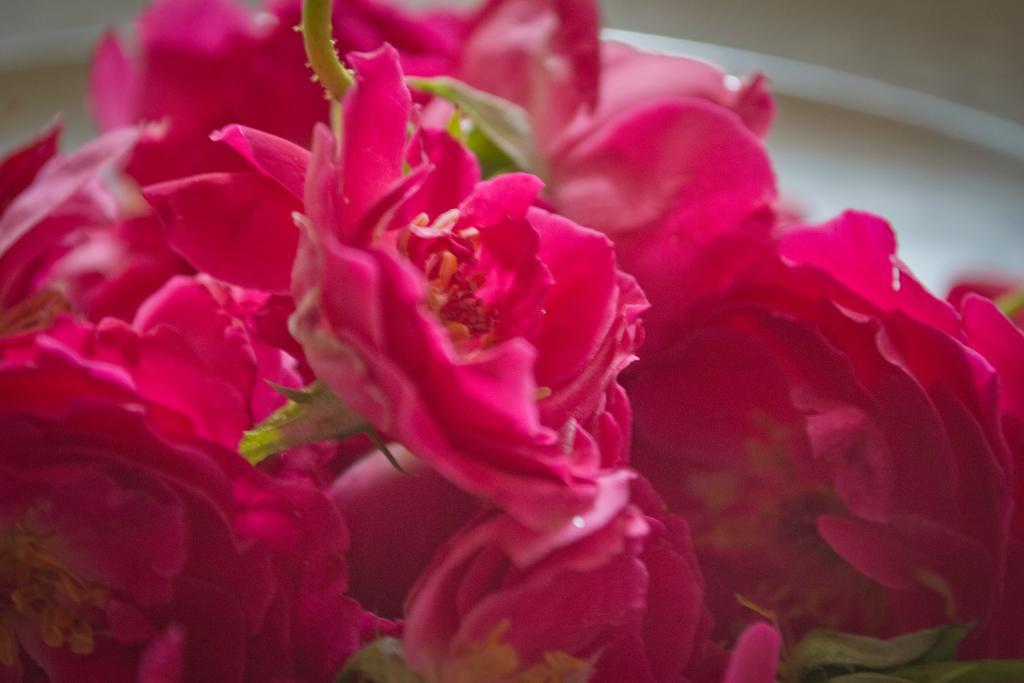Can you describe this image briefly? In this image, we can see some pink color flowers. 